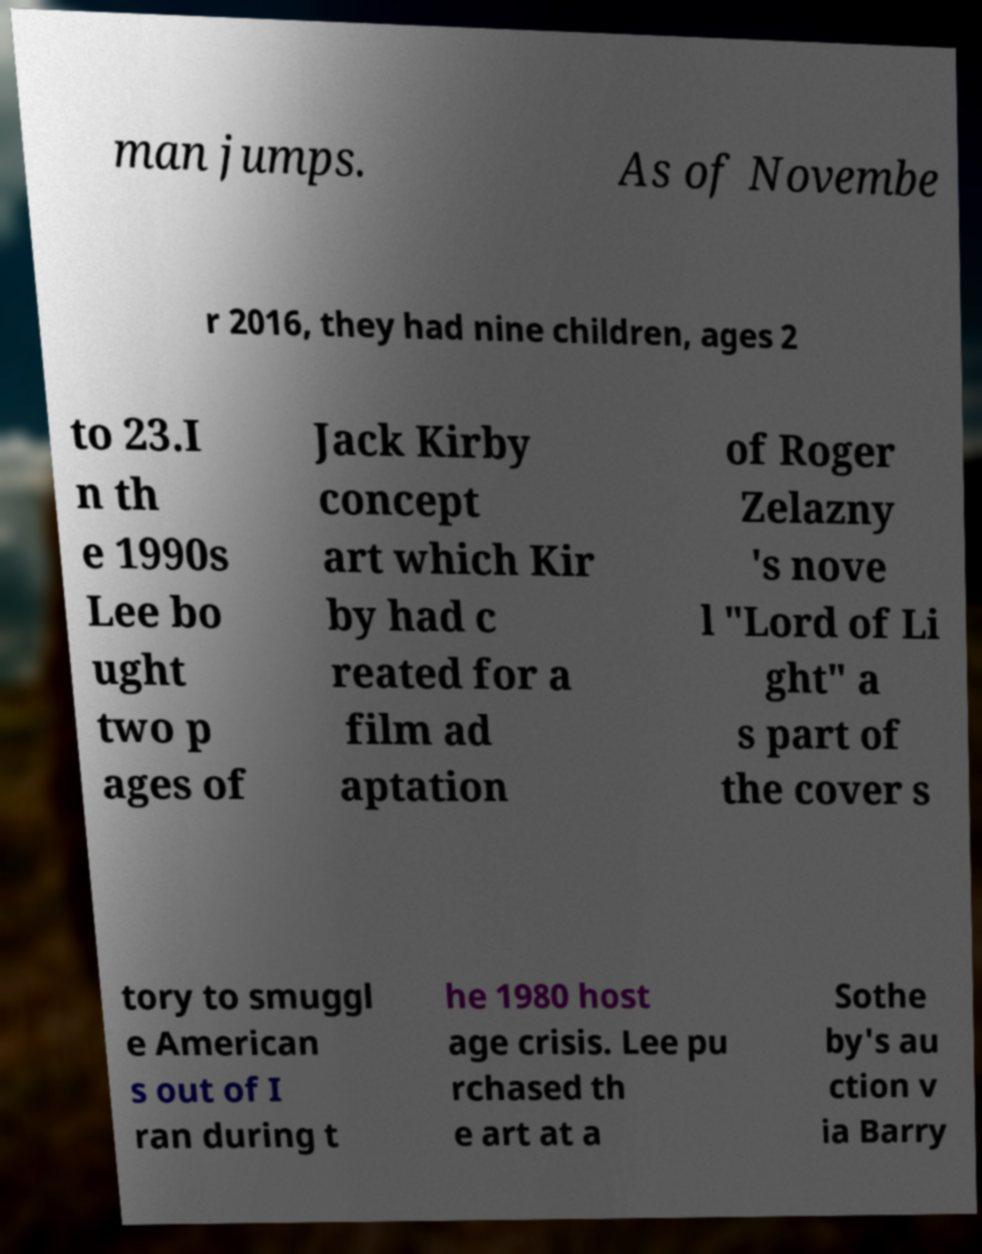Can you read and provide the text displayed in the image?This photo seems to have some interesting text. Can you extract and type it out for me? man jumps. As of Novembe r 2016, they had nine children, ages 2 to 23.I n th e 1990s Lee bo ught two p ages of Jack Kirby concept art which Kir by had c reated for a film ad aptation of Roger Zelazny 's nove l "Lord of Li ght" a s part of the cover s tory to smuggl e American s out of I ran during t he 1980 host age crisis. Lee pu rchased th e art at a Sothe by's au ction v ia Barry 